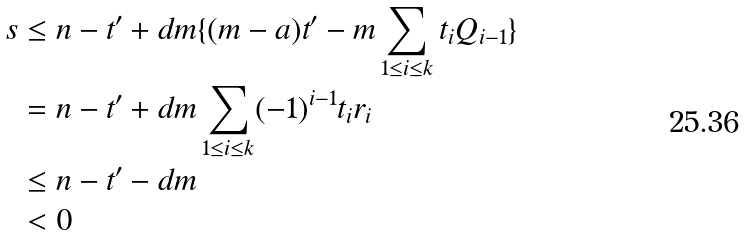<formula> <loc_0><loc_0><loc_500><loc_500>s & \leq n - t ^ { \prime } + d m \{ ( m - a ) t ^ { \prime } - m \sum _ { 1 \leq i \leq k } t _ { i } Q _ { i - 1 } \} \\ & = n - t ^ { \prime } + d m \sum _ { 1 \leq i \leq k } ( - 1 ) ^ { i - 1 } t _ { i } r _ { i } \\ & \leq n - t ^ { \prime } - d m \\ & < 0</formula> 